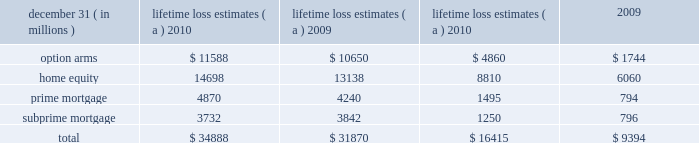Management 2019s discussion and analysis 132 jpmorgan chase & co./2010 annual report unpaid principal balance due to negative amortization of option arms was $ 24 million and $ 78 million at december 31 , 2010 and 2009 , respectively .
The firm estimates the following balances of option arm loans will experience a recast that results in a payment increase : $ 72 million in 2011 , $ 241 million in 2012 and $ 784 million in 2013 .
The firm did not originate option arms and new originations of option arms were discontinued by washington mutual prior to the date of jpmorgan chase 2019s acquisition of its banking operations .
Subprime mortgages at december 31 , 2010 were $ 11.3 billion , compared with $ 12.5 billion at december 31 , 2009 .
The decrease was due to paydowns and charge-offs on delinquent loans , partially offset by the addition of loans as a result of the adoption of the accounting guidance related to vies .
Late-stage delinquencies remained elevated but continued to improve , albeit at a slower rate during the second half of the year , while early-stage delinquencies stabilized at an elevated level during this period .
Nonaccrual loans improved largely as a result of the improvement in late-stage delinquencies .
Charge-offs reflected modest improvement .
Auto : auto loans at december 31 , 2010 , were $ 48.4 billion , compared with $ 46.0 billion at december 31 , 2009 .
Delinquent and nonaccrual loans have decreased .
In addition , net charge-offs have declined 52% ( 52 % ) from the prior year .
Provision expense de- creased due to favorable loss severity as a result of a strong used- car market nationwide and reduced loss frequency due to the tightening of underwriting criteria in earlier periods .
The auto loan portfolio reflected a high concentration of prime quality credits .
Business banking : business banking loans at december 31 , 2010 , were $ 16.8 billion , compared with $ 17.0 billion at december 31 , 2009 .
The decrease was primarily a result of run-off of the washington mutual portfolio and charge-offs on delinquent loans .
These loans primarily include loans which are highly collateralized , often with personal loan guarantees .
Nonaccrual loans continued to remain elevated .
After having increased during the first half of 2010 , nonaccrual loans as of december 31 , 2010 , declined to year-end 2009 levels .
Student and other : student and other loans at december 31 , 2010 , including loans held-for-sale , were $ 15.3 billion , compared with $ 16.4 billion at december 31 , 2009 .
Other loans primarily include other secured and unsecured consumer loans .
Delinquencies reflected some stabilization in the second half of 2010 , but remained elevated .
Charge-offs during 2010 remained relatively flat with 2009 levels reflecting the impact of elevated unemployment levels .
Purchased credit-impaired loans : pci loans at december 31 , 2010 , were $ 72.8 billion compared with $ 81.2 billion at december 31 , 2009 .
This portfolio represents loans acquired in the washing- ton mutual transaction that were recorded at fair value at the time of acquisition .
That fair value included an estimate of credit losses expected to be realized over the remaining lives of the loans , and therefore no allowance for loan losses was recorded for these loans as of the acquisition date .
The firm regularly updates the amount of principal and interest cash flows expected to be collected for these loans .
Probable decreases in expected loan principal cash flows would trigger the recognition of impairment through the provision for loan losses .
Probable and significant increases in expected cash flows ( e.g. , decreased principal credit losses , the net benefit of modifications ) would first reverse any previously recorded allowance for loan losses , with any remaining increase in the expected cash flows recognized prospectively in interest income over the remaining estimated lives of the underlying loans .
During 2010 , management concluded as part of the firm 2019s regular assessment of the pci pools that it was probable that higher expected principal credit losses would result in a decrease in expected cash flows .
Accordingly , the firm recognized an aggregate $ 3.4 billion impairment related to the home equity , prime mortgage , option arm and subprime mortgage pci portfolios .
As a result of this impairment , the firm 2019s allowance for loan losses for the home equity , prime mortgage , option arm and subprime mortgage pci portfolios was $ 1.6 billion , $ 1.8 billion , $ 1.5 billion and $ 98 million , respectively , at december 31 , 2010 , compared with an allowance for loan losses of $ 1.1 billion and $ 491 million for the prime mortgage and option arm pci portfolios , respectively , at december 31 , 2009 .
Approximately 39% ( 39 % ) of the option arm borrowers were delinquent , 5% ( 5 % ) were making interest-only or negatively amortizing payments , and 56% ( 56 % ) were making amortizing payments .
Approximately 50% ( 50 % ) of current borrowers are subject to risk of payment shock due to future payment recast ; substantially all of the remaining loans have been modified to a fixed rate fully amortizing loan .
The cumulative amount of unpaid interest added to the unpaid principal balance of the option arm pci pool was $ 1.4 billion and $ 1.9 billion at de- cember 31 , 2010 and 2009 , respectively .
The firm estimates the following balances of option arm pci loans will experience a recast that results in a payment increase : $ 1.2 billion in 2011 , $ 2.7 billion in 2012 and $ 508 million in 2013 .
The table provides a summary of lifetime loss estimates included in both the nonaccretable difference and the allowance for loan losses .
Principal charge-offs will not be recorded on these pools until the nonaccretable difference has been fully depleted .
Lifetime loss estimates ( a ) ltd liquidation losses ( b ) .
( a ) includes the original nonaccretable difference established in purchase accounting of $ 30.5 billion for principal losses only .
The remaining nonaccretable difference for principal losses only was $ 14.1 billion and $ 21.1 billion at december 31 , 2010 and 2009 , respectively .
All probable increases in principal losses and foregone interest subsequent to the purchase date are reflected in the allowance for loan losses .
( b ) life-to-date ( 201cltd 201d ) liquidation losses represent realization of loss upon loan resolution. .
The nonaccretable difference for principal losses was how much of the 2010 lifetime loss estimates? 
Computations: (34888 / 1000)
Answer: 34.888. Management 2019s discussion and analysis 132 jpmorgan chase & co./2010 annual report unpaid principal balance due to negative amortization of option arms was $ 24 million and $ 78 million at december 31 , 2010 and 2009 , respectively .
The firm estimates the following balances of option arm loans will experience a recast that results in a payment increase : $ 72 million in 2011 , $ 241 million in 2012 and $ 784 million in 2013 .
The firm did not originate option arms and new originations of option arms were discontinued by washington mutual prior to the date of jpmorgan chase 2019s acquisition of its banking operations .
Subprime mortgages at december 31 , 2010 were $ 11.3 billion , compared with $ 12.5 billion at december 31 , 2009 .
The decrease was due to paydowns and charge-offs on delinquent loans , partially offset by the addition of loans as a result of the adoption of the accounting guidance related to vies .
Late-stage delinquencies remained elevated but continued to improve , albeit at a slower rate during the second half of the year , while early-stage delinquencies stabilized at an elevated level during this period .
Nonaccrual loans improved largely as a result of the improvement in late-stage delinquencies .
Charge-offs reflected modest improvement .
Auto : auto loans at december 31 , 2010 , were $ 48.4 billion , compared with $ 46.0 billion at december 31 , 2009 .
Delinquent and nonaccrual loans have decreased .
In addition , net charge-offs have declined 52% ( 52 % ) from the prior year .
Provision expense de- creased due to favorable loss severity as a result of a strong used- car market nationwide and reduced loss frequency due to the tightening of underwriting criteria in earlier periods .
The auto loan portfolio reflected a high concentration of prime quality credits .
Business banking : business banking loans at december 31 , 2010 , were $ 16.8 billion , compared with $ 17.0 billion at december 31 , 2009 .
The decrease was primarily a result of run-off of the washington mutual portfolio and charge-offs on delinquent loans .
These loans primarily include loans which are highly collateralized , often with personal loan guarantees .
Nonaccrual loans continued to remain elevated .
After having increased during the first half of 2010 , nonaccrual loans as of december 31 , 2010 , declined to year-end 2009 levels .
Student and other : student and other loans at december 31 , 2010 , including loans held-for-sale , were $ 15.3 billion , compared with $ 16.4 billion at december 31 , 2009 .
Other loans primarily include other secured and unsecured consumer loans .
Delinquencies reflected some stabilization in the second half of 2010 , but remained elevated .
Charge-offs during 2010 remained relatively flat with 2009 levels reflecting the impact of elevated unemployment levels .
Purchased credit-impaired loans : pci loans at december 31 , 2010 , were $ 72.8 billion compared with $ 81.2 billion at december 31 , 2009 .
This portfolio represents loans acquired in the washing- ton mutual transaction that were recorded at fair value at the time of acquisition .
That fair value included an estimate of credit losses expected to be realized over the remaining lives of the loans , and therefore no allowance for loan losses was recorded for these loans as of the acquisition date .
The firm regularly updates the amount of principal and interest cash flows expected to be collected for these loans .
Probable decreases in expected loan principal cash flows would trigger the recognition of impairment through the provision for loan losses .
Probable and significant increases in expected cash flows ( e.g. , decreased principal credit losses , the net benefit of modifications ) would first reverse any previously recorded allowance for loan losses , with any remaining increase in the expected cash flows recognized prospectively in interest income over the remaining estimated lives of the underlying loans .
During 2010 , management concluded as part of the firm 2019s regular assessment of the pci pools that it was probable that higher expected principal credit losses would result in a decrease in expected cash flows .
Accordingly , the firm recognized an aggregate $ 3.4 billion impairment related to the home equity , prime mortgage , option arm and subprime mortgage pci portfolios .
As a result of this impairment , the firm 2019s allowance for loan losses for the home equity , prime mortgage , option arm and subprime mortgage pci portfolios was $ 1.6 billion , $ 1.8 billion , $ 1.5 billion and $ 98 million , respectively , at december 31 , 2010 , compared with an allowance for loan losses of $ 1.1 billion and $ 491 million for the prime mortgage and option arm pci portfolios , respectively , at december 31 , 2009 .
Approximately 39% ( 39 % ) of the option arm borrowers were delinquent , 5% ( 5 % ) were making interest-only or negatively amortizing payments , and 56% ( 56 % ) were making amortizing payments .
Approximately 50% ( 50 % ) of current borrowers are subject to risk of payment shock due to future payment recast ; substantially all of the remaining loans have been modified to a fixed rate fully amortizing loan .
The cumulative amount of unpaid interest added to the unpaid principal balance of the option arm pci pool was $ 1.4 billion and $ 1.9 billion at de- cember 31 , 2010 and 2009 , respectively .
The firm estimates the following balances of option arm pci loans will experience a recast that results in a payment increase : $ 1.2 billion in 2011 , $ 2.7 billion in 2012 and $ 508 million in 2013 .
The table provides a summary of lifetime loss estimates included in both the nonaccretable difference and the allowance for loan losses .
Principal charge-offs will not be recorded on these pools until the nonaccretable difference has been fully depleted .
Lifetime loss estimates ( a ) ltd liquidation losses ( b ) .
( a ) includes the original nonaccretable difference established in purchase accounting of $ 30.5 billion for principal losses only .
The remaining nonaccretable difference for principal losses only was $ 14.1 billion and $ 21.1 billion at december 31 , 2010 and 2009 , respectively .
All probable increases in principal losses and foregone interest subsequent to the purchase date are reflected in the allowance for loan losses .
( b ) life-to-date ( 201cltd 201d ) liquidation losses represent realization of loss upon loan resolution. .
In the consumer loan business , what percent of the adjustable rate borrowers weren't making any principal payments? 
Computations: (56 + 5)
Answer: 61.0. Management 2019s discussion and analysis 132 jpmorgan chase & co./2010 annual report unpaid principal balance due to negative amortization of option arms was $ 24 million and $ 78 million at december 31 , 2010 and 2009 , respectively .
The firm estimates the following balances of option arm loans will experience a recast that results in a payment increase : $ 72 million in 2011 , $ 241 million in 2012 and $ 784 million in 2013 .
The firm did not originate option arms and new originations of option arms were discontinued by washington mutual prior to the date of jpmorgan chase 2019s acquisition of its banking operations .
Subprime mortgages at december 31 , 2010 were $ 11.3 billion , compared with $ 12.5 billion at december 31 , 2009 .
The decrease was due to paydowns and charge-offs on delinquent loans , partially offset by the addition of loans as a result of the adoption of the accounting guidance related to vies .
Late-stage delinquencies remained elevated but continued to improve , albeit at a slower rate during the second half of the year , while early-stage delinquencies stabilized at an elevated level during this period .
Nonaccrual loans improved largely as a result of the improvement in late-stage delinquencies .
Charge-offs reflected modest improvement .
Auto : auto loans at december 31 , 2010 , were $ 48.4 billion , compared with $ 46.0 billion at december 31 , 2009 .
Delinquent and nonaccrual loans have decreased .
In addition , net charge-offs have declined 52% ( 52 % ) from the prior year .
Provision expense de- creased due to favorable loss severity as a result of a strong used- car market nationwide and reduced loss frequency due to the tightening of underwriting criteria in earlier periods .
The auto loan portfolio reflected a high concentration of prime quality credits .
Business banking : business banking loans at december 31 , 2010 , were $ 16.8 billion , compared with $ 17.0 billion at december 31 , 2009 .
The decrease was primarily a result of run-off of the washington mutual portfolio and charge-offs on delinquent loans .
These loans primarily include loans which are highly collateralized , often with personal loan guarantees .
Nonaccrual loans continued to remain elevated .
After having increased during the first half of 2010 , nonaccrual loans as of december 31 , 2010 , declined to year-end 2009 levels .
Student and other : student and other loans at december 31 , 2010 , including loans held-for-sale , were $ 15.3 billion , compared with $ 16.4 billion at december 31 , 2009 .
Other loans primarily include other secured and unsecured consumer loans .
Delinquencies reflected some stabilization in the second half of 2010 , but remained elevated .
Charge-offs during 2010 remained relatively flat with 2009 levels reflecting the impact of elevated unemployment levels .
Purchased credit-impaired loans : pci loans at december 31 , 2010 , were $ 72.8 billion compared with $ 81.2 billion at december 31 , 2009 .
This portfolio represents loans acquired in the washing- ton mutual transaction that were recorded at fair value at the time of acquisition .
That fair value included an estimate of credit losses expected to be realized over the remaining lives of the loans , and therefore no allowance for loan losses was recorded for these loans as of the acquisition date .
The firm regularly updates the amount of principal and interest cash flows expected to be collected for these loans .
Probable decreases in expected loan principal cash flows would trigger the recognition of impairment through the provision for loan losses .
Probable and significant increases in expected cash flows ( e.g. , decreased principal credit losses , the net benefit of modifications ) would first reverse any previously recorded allowance for loan losses , with any remaining increase in the expected cash flows recognized prospectively in interest income over the remaining estimated lives of the underlying loans .
During 2010 , management concluded as part of the firm 2019s regular assessment of the pci pools that it was probable that higher expected principal credit losses would result in a decrease in expected cash flows .
Accordingly , the firm recognized an aggregate $ 3.4 billion impairment related to the home equity , prime mortgage , option arm and subprime mortgage pci portfolios .
As a result of this impairment , the firm 2019s allowance for loan losses for the home equity , prime mortgage , option arm and subprime mortgage pci portfolios was $ 1.6 billion , $ 1.8 billion , $ 1.5 billion and $ 98 million , respectively , at december 31 , 2010 , compared with an allowance for loan losses of $ 1.1 billion and $ 491 million for the prime mortgage and option arm pci portfolios , respectively , at december 31 , 2009 .
Approximately 39% ( 39 % ) of the option arm borrowers were delinquent , 5% ( 5 % ) were making interest-only or negatively amortizing payments , and 56% ( 56 % ) were making amortizing payments .
Approximately 50% ( 50 % ) of current borrowers are subject to risk of payment shock due to future payment recast ; substantially all of the remaining loans have been modified to a fixed rate fully amortizing loan .
The cumulative amount of unpaid interest added to the unpaid principal balance of the option arm pci pool was $ 1.4 billion and $ 1.9 billion at de- cember 31 , 2010 and 2009 , respectively .
The firm estimates the following balances of option arm pci loans will experience a recast that results in a payment increase : $ 1.2 billion in 2011 , $ 2.7 billion in 2012 and $ 508 million in 2013 .
The table provides a summary of lifetime loss estimates included in both the nonaccretable difference and the allowance for loan losses .
Principal charge-offs will not be recorded on these pools until the nonaccretable difference has been fully depleted .
Lifetime loss estimates ( a ) ltd liquidation losses ( b ) .
( a ) includes the original nonaccretable difference established in purchase accounting of $ 30.5 billion for principal losses only .
The remaining nonaccretable difference for principal losses only was $ 14.1 billion and $ 21.1 billion at december 31 , 2010 and 2009 , respectively .
All probable increases in principal losses and foregone interest subsequent to the purchase date are reflected in the allowance for loan losses .
( b ) life-to-date ( 201cltd 201d ) liquidation losses represent realization of loss upon loan resolution. .
In 2010 what was the percent of the lifetime loss estimates from home equity? 
Computations: (14698 / 34888)
Answer: 0.42129. 